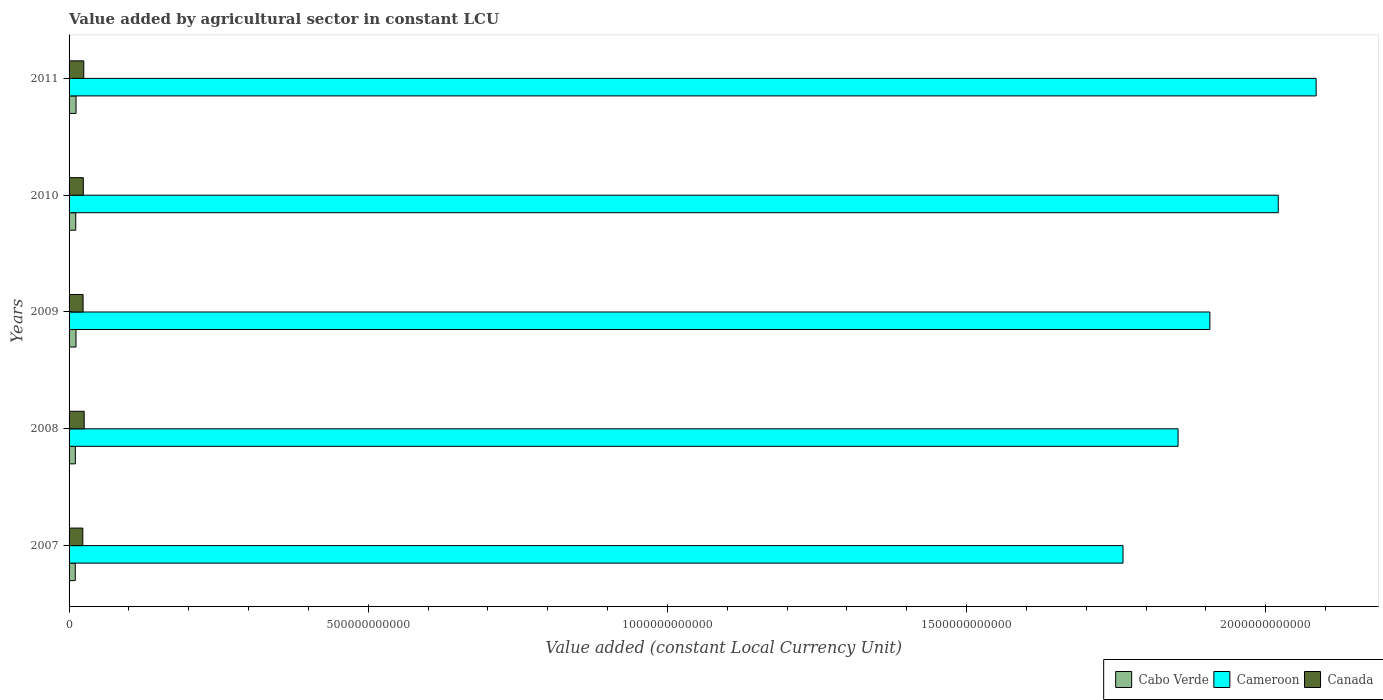How many different coloured bars are there?
Ensure brevity in your answer.  3. How many groups of bars are there?
Ensure brevity in your answer.  5. Are the number of bars on each tick of the Y-axis equal?
Your answer should be very brief. Yes. How many bars are there on the 4th tick from the top?
Give a very brief answer. 3. How many bars are there on the 3rd tick from the bottom?
Keep it short and to the point. 3. What is the value added by agricultural sector in Canada in 2007?
Provide a short and direct response. 2.29e+1. Across all years, what is the maximum value added by agricultural sector in Canada?
Your response must be concise. 2.52e+1. Across all years, what is the minimum value added by agricultural sector in Canada?
Offer a terse response. 2.29e+1. In which year was the value added by agricultural sector in Cabo Verde minimum?
Offer a terse response. 2007. What is the total value added by agricultural sector in Cabo Verde in the graph?
Your answer should be very brief. 5.53e+1. What is the difference between the value added by agricultural sector in Canada in 2007 and that in 2009?
Your response must be concise. -4.77e+08. What is the difference between the value added by agricultural sector in Cabo Verde in 2009 and the value added by agricultural sector in Cameroon in 2007?
Make the answer very short. -1.75e+12. What is the average value added by agricultural sector in Cameroon per year?
Offer a terse response. 1.93e+12. In the year 2008, what is the difference between the value added by agricultural sector in Cabo Verde and value added by agricultural sector in Canada?
Offer a very short reply. -1.47e+1. In how many years, is the value added by agricultural sector in Canada greater than 1800000000000 LCU?
Give a very brief answer. 0. What is the ratio of the value added by agricultural sector in Canada in 2008 to that in 2009?
Keep it short and to the point. 1.08. Is the value added by agricultural sector in Cameroon in 2009 less than that in 2010?
Ensure brevity in your answer.  Yes. What is the difference between the highest and the second highest value added by agricultural sector in Cabo Verde?
Provide a short and direct response. 6.91e+07. What is the difference between the highest and the lowest value added by agricultural sector in Cabo Verde?
Keep it short and to the point. 1.27e+09. In how many years, is the value added by agricultural sector in Cameroon greater than the average value added by agricultural sector in Cameroon taken over all years?
Provide a succinct answer. 2. What does the 3rd bar from the top in 2011 represents?
Provide a short and direct response. Cabo Verde. What does the 2nd bar from the bottom in 2011 represents?
Provide a succinct answer. Cameroon. How many bars are there?
Ensure brevity in your answer.  15. How many years are there in the graph?
Your answer should be compact. 5. What is the difference between two consecutive major ticks on the X-axis?
Your answer should be very brief. 5.00e+11. Are the values on the major ticks of X-axis written in scientific E-notation?
Keep it short and to the point. No. Where does the legend appear in the graph?
Offer a very short reply. Bottom right. What is the title of the graph?
Keep it short and to the point. Value added by agricultural sector in constant LCU. Does "Azerbaijan" appear as one of the legend labels in the graph?
Make the answer very short. No. What is the label or title of the X-axis?
Keep it short and to the point. Value added (constant Local Currency Unit). What is the label or title of the Y-axis?
Offer a very short reply. Years. What is the Value added (constant Local Currency Unit) of Cabo Verde in 2007?
Provide a short and direct response. 1.04e+1. What is the Value added (constant Local Currency Unit) in Cameroon in 2007?
Provide a short and direct response. 1.76e+12. What is the Value added (constant Local Currency Unit) in Canada in 2007?
Give a very brief answer. 2.29e+1. What is the Value added (constant Local Currency Unit) of Cabo Verde in 2008?
Offer a terse response. 1.05e+1. What is the Value added (constant Local Currency Unit) in Cameroon in 2008?
Provide a succinct answer. 1.85e+12. What is the Value added (constant Local Currency Unit) in Canada in 2008?
Your answer should be very brief. 2.52e+1. What is the Value added (constant Local Currency Unit) of Cabo Verde in 2009?
Your response must be concise. 1.16e+1. What is the Value added (constant Local Currency Unit) in Cameroon in 2009?
Offer a very short reply. 1.91e+12. What is the Value added (constant Local Currency Unit) in Canada in 2009?
Offer a very short reply. 2.34e+1. What is the Value added (constant Local Currency Unit) in Cabo Verde in 2010?
Provide a succinct answer. 1.12e+1. What is the Value added (constant Local Currency Unit) in Cameroon in 2010?
Offer a very short reply. 2.02e+12. What is the Value added (constant Local Currency Unit) in Canada in 2010?
Provide a short and direct response. 2.38e+1. What is the Value added (constant Local Currency Unit) of Cabo Verde in 2011?
Your answer should be compact. 1.17e+1. What is the Value added (constant Local Currency Unit) of Cameroon in 2011?
Your answer should be very brief. 2.08e+12. What is the Value added (constant Local Currency Unit) of Canada in 2011?
Ensure brevity in your answer.  2.46e+1. Across all years, what is the maximum Value added (constant Local Currency Unit) in Cabo Verde?
Provide a short and direct response. 1.17e+1. Across all years, what is the maximum Value added (constant Local Currency Unit) in Cameroon?
Give a very brief answer. 2.08e+12. Across all years, what is the maximum Value added (constant Local Currency Unit) of Canada?
Your response must be concise. 2.52e+1. Across all years, what is the minimum Value added (constant Local Currency Unit) of Cabo Verde?
Ensure brevity in your answer.  1.04e+1. Across all years, what is the minimum Value added (constant Local Currency Unit) of Cameroon?
Ensure brevity in your answer.  1.76e+12. Across all years, what is the minimum Value added (constant Local Currency Unit) of Canada?
Provide a succinct answer. 2.29e+1. What is the total Value added (constant Local Currency Unit) in Cabo Verde in the graph?
Your response must be concise. 5.53e+1. What is the total Value added (constant Local Currency Unit) of Cameroon in the graph?
Ensure brevity in your answer.  9.63e+12. What is the total Value added (constant Local Currency Unit) in Canada in the graph?
Keep it short and to the point. 1.20e+11. What is the difference between the Value added (constant Local Currency Unit) of Cabo Verde in 2007 and that in 2008?
Offer a terse response. -9.91e+07. What is the difference between the Value added (constant Local Currency Unit) of Cameroon in 2007 and that in 2008?
Keep it short and to the point. -9.20e+1. What is the difference between the Value added (constant Local Currency Unit) of Canada in 2007 and that in 2008?
Your answer should be very brief. -2.30e+09. What is the difference between the Value added (constant Local Currency Unit) of Cabo Verde in 2007 and that in 2009?
Offer a terse response. -1.20e+09. What is the difference between the Value added (constant Local Currency Unit) of Cameroon in 2007 and that in 2009?
Your answer should be compact. -1.45e+11. What is the difference between the Value added (constant Local Currency Unit) of Canada in 2007 and that in 2009?
Make the answer very short. -4.77e+08. What is the difference between the Value added (constant Local Currency Unit) in Cabo Verde in 2007 and that in 2010?
Provide a succinct answer. -7.83e+08. What is the difference between the Value added (constant Local Currency Unit) of Cameroon in 2007 and that in 2010?
Provide a succinct answer. -2.59e+11. What is the difference between the Value added (constant Local Currency Unit) in Canada in 2007 and that in 2010?
Your answer should be compact. -8.49e+08. What is the difference between the Value added (constant Local Currency Unit) in Cabo Verde in 2007 and that in 2011?
Your answer should be compact. -1.27e+09. What is the difference between the Value added (constant Local Currency Unit) of Cameroon in 2007 and that in 2011?
Provide a short and direct response. -3.23e+11. What is the difference between the Value added (constant Local Currency Unit) of Canada in 2007 and that in 2011?
Keep it short and to the point. -1.64e+09. What is the difference between the Value added (constant Local Currency Unit) in Cabo Verde in 2008 and that in 2009?
Provide a short and direct response. -1.10e+09. What is the difference between the Value added (constant Local Currency Unit) of Cameroon in 2008 and that in 2009?
Your answer should be very brief. -5.31e+1. What is the difference between the Value added (constant Local Currency Unit) of Canada in 2008 and that in 2009?
Make the answer very short. 1.82e+09. What is the difference between the Value added (constant Local Currency Unit) in Cabo Verde in 2008 and that in 2010?
Your answer should be very brief. -6.84e+08. What is the difference between the Value added (constant Local Currency Unit) in Cameroon in 2008 and that in 2010?
Provide a succinct answer. -1.67e+11. What is the difference between the Value added (constant Local Currency Unit) in Canada in 2008 and that in 2010?
Offer a very short reply. 1.45e+09. What is the difference between the Value added (constant Local Currency Unit) of Cabo Verde in 2008 and that in 2011?
Give a very brief answer. -1.17e+09. What is the difference between the Value added (constant Local Currency Unit) of Cameroon in 2008 and that in 2011?
Provide a short and direct response. -2.31e+11. What is the difference between the Value added (constant Local Currency Unit) of Canada in 2008 and that in 2011?
Offer a very short reply. 6.58e+08. What is the difference between the Value added (constant Local Currency Unit) in Cabo Verde in 2009 and that in 2010?
Your response must be concise. 4.20e+08. What is the difference between the Value added (constant Local Currency Unit) in Cameroon in 2009 and that in 2010?
Your answer should be compact. -1.14e+11. What is the difference between the Value added (constant Local Currency Unit) of Canada in 2009 and that in 2010?
Provide a succinct answer. -3.73e+08. What is the difference between the Value added (constant Local Currency Unit) in Cabo Verde in 2009 and that in 2011?
Provide a succinct answer. -6.91e+07. What is the difference between the Value added (constant Local Currency Unit) of Cameroon in 2009 and that in 2011?
Provide a succinct answer. -1.78e+11. What is the difference between the Value added (constant Local Currency Unit) of Canada in 2009 and that in 2011?
Give a very brief answer. -1.16e+09. What is the difference between the Value added (constant Local Currency Unit) in Cabo Verde in 2010 and that in 2011?
Keep it short and to the point. -4.90e+08. What is the difference between the Value added (constant Local Currency Unit) of Cameroon in 2010 and that in 2011?
Your response must be concise. -6.33e+1. What is the difference between the Value added (constant Local Currency Unit) of Canada in 2010 and that in 2011?
Offer a terse response. -7.89e+08. What is the difference between the Value added (constant Local Currency Unit) of Cabo Verde in 2007 and the Value added (constant Local Currency Unit) of Cameroon in 2008?
Your response must be concise. -1.84e+12. What is the difference between the Value added (constant Local Currency Unit) of Cabo Verde in 2007 and the Value added (constant Local Currency Unit) of Canada in 2008?
Your answer should be compact. -1.48e+1. What is the difference between the Value added (constant Local Currency Unit) of Cameroon in 2007 and the Value added (constant Local Currency Unit) of Canada in 2008?
Provide a succinct answer. 1.74e+12. What is the difference between the Value added (constant Local Currency Unit) in Cabo Verde in 2007 and the Value added (constant Local Currency Unit) in Cameroon in 2009?
Make the answer very short. -1.90e+12. What is the difference between the Value added (constant Local Currency Unit) in Cabo Verde in 2007 and the Value added (constant Local Currency Unit) in Canada in 2009?
Provide a succinct answer. -1.30e+1. What is the difference between the Value added (constant Local Currency Unit) of Cameroon in 2007 and the Value added (constant Local Currency Unit) of Canada in 2009?
Your response must be concise. 1.74e+12. What is the difference between the Value added (constant Local Currency Unit) in Cabo Verde in 2007 and the Value added (constant Local Currency Unit) in Cameroon in 2010?
Your response must be concise. -2.01e+12. What is the difference between the Value added (constant Local Currency Unit) in Cabo Verde in 2007 and the Value added (constant Local Currency Unit) in Canada in 2010?
Your answer should be compact. -1.34e+1. What is the difference between the Value added (constant Local Currency Unit) of Cameroon in 2007 and the Value added (constant Local Currency Unit) of Canada in 2010?
Keep it short and to the point. 1.74e+12. What is the difference between the Value added (constant Local Currency Unit) of Cabo Verde in 2007 and the Value added (constant Local Currency Unit) of Cameroon in 2011?
Your answer should be very brief. -2.07e+12. What is the difference between the Value added (constant Local Currency Unit) in Cabo Verde in 2007 and the Value added (constant Local Currency Unit) in Canada in 2011?
Make the answer very short. -1.42e+1. What is the difference between the Value added (constant Local Currency Unit) in Cameroon in 2007 and the Value added (constant Local Currency Unit) in Canada in 2011?
Your response must be concise. 1.74e+12. What is the difference between the Value added (constant Local Currency Unit) of Cabo Verde in 2008 and the Value added (constant Local Currency Unit) of Cameroon in 2009?
Give a very brief answer. -1.90e+12. What is the difference between the Value added (constant Local Currency Unit) of Cabo Verde in 2008 and the Value added (constant Local Currency Unit) of Canada in 2009?
Provide a succinct answer. -1.29e+1. What is the difference between the Value added (constant Local Currency Unit) in Cameroon in 2008 and the Value added (constant Local Currency Unit) in Canada in 2009?
Your answer should be very brief. 1.83e+12. What is the difference between the Value added (constant Local Currency Unit) of Cabo Verde in 2008 and the Value added (constant Local Currency Unit) of Cameroon in 2010?
Your answer should be compact. -2.01e+12. What is the difference between the Value added (constant Local Currency Unit) in Cabo Verde in 2008 and the Value added (constant Local Currency Unit) in Canada in 2010?
Provide a succinct answer. -1.33e+1. What is the difference between the Value added (constant Local Currency Unit) in Cameroon in 2008 and the Value added (constant Local Currency Unit) in Canada in 2010?
Give a very brief answer. 1.83e+12. What is the difference between the Value added (constant Local Currency Unit) of Cabo Verde in 2008 and the Value added (constant Local Currency Unit) of Cameroon in 2011?
Your answer should be compact. -2.07e+12. What is the difference between the Value added (constant Local Currency Unit) of Cabo Verde in 2008 and the Value added (constant Local Currency Unit) of Canada in 2011?
Make the answer very short. -1.41e+1. What is the difference between the Value added (constant Local Currency Unit) of Cameroon in 2008 and the Value added (constant Local Currency Unit) of Canada in 2011?
Keep it short and to the point. 1.83e+12. What is the difference between the Value added (constant Local Currency Unit) of Cabo Verde in 2009 and the Value added (constant Local Currency Unit) of Cameroon in 2010?
Your answer should be very brief. -2.01e+12. What is the difference between the Value added (constant Local Currency Unit) in Cabo Verde in 2009 and the Value added (constant Local Currency Unit) in Canada in 2010?
Your response must be concise. -1.22e+1. What is the difference between the Value added (constant Local Currency Unit) of Cameroon in 2009 and the Value added (constant Local Currency Unit) of Canada in 2010?
Make the answer very short. 1.88e+12. What is the difference between the Value added (constant Local Currency Unit) in Cabo Verde in 2009 and the Value added (constant Local Currency Unit) in Cameroon in 2011?
Give a very brief answer. -2.07e+12. What is the difference between the Value added (constant Local Currency Unit) of Cabo Verde in 2009 and the Value added (constant Local Currency Unit) of Canada in 2011?
Your response must be concise. -1.30e+1. What is the difference between the Value added (constant Local Currency Unit) of Cameroon in 2009 and the Value added (constant Local Currency Unit) of Canada in 2011?
Offer a very short reply. 1.88e+12. What is the difference between the Value added (constant Local Currency Unit) of Cabo Verde in 2010 and the Value added (constant Local Currency Unit) of Cameroon in 2011?
Offer a terse response. -2.07e+12. What is the difference between the Value added (constant Local Currency Unit) in Cabo Verde in 2010 and the Value added (constant Local Currency Unit) in Canada in 2011?
Keep it short and to the point. -1.34e+1. What is the difference between the Value added (constant Local Currency Unit) in Cameroon in 2010 and the Value added (constant Local Currency Unit) in Canada in 2011?
Keep it short and to the point. 2.00e+12. What is the average Value added (constant Local Currency Unit) in Cabo Verde per year?
Provide a succinct answer. 1.11e+1. What is the average Value added (constant Local Currency Unit) in Cameroon per year?
Your answer should be compact. 1.93e+12. What is the average Value added (constant Local Currency Unit) of Canada per year?
Your response must be concise. 2.40e+1. In the year 2007, what is the difference between the Value added (constant Local Currency Unit) of Cabo Verde and Value added (constant Local Currency Unit) of Cameroon?
Your answer should be very brief. -1.75e+12. In the year 2007, what is the difference between the Value added (constant Local Currency Unit) in Cabo Verde and Value added (constant Local Currency Unit) in Canada?
Provide a succinct answer. -1.25e+1. In the year 2007, what is the difference between the Value added (constant Local Currency Unit) of Cameroon and Value added (constant Local Currency Unit) of Canada?
Your answer should be compact. 1.74e+12. In the year 2008, what is the difference between the Value added (constant Local Currency Unit) in Cabo Verde and Value added (constant Local Currency Unit) in Cameroon?
Provide a short and direct response. -1.84e+12. In the year 2008, what is the difference between the Value added (constant Local Currency Unit) of Cabo Verde and Value added (constant Local Currency Unit) of Canada?
Your answer should be very brief. -1.47e+1. In the year 2008, what is the difference between the Value added (constant Local Currency Unit) of Cameroon and Value added (constant Local Currency Unit) of Canada?
Offer a terse response. 1.83e+12. In the year 2009, what is the difference between the Value added (constant Local Currency Unit) of Cabo Verde and Value added (constant Local Currency Unit) of Cameroon?
Ensure brevity in your answer.  -1.90e+12. In the year 2009, what is the difference between the Value added (constant Local Currency Unit) of Cabo Verde and Value added (constant Local Currency Unit) of Canada?
Offer a very short reply. -1.18e+1. In the year 2009, what is the difference between the Value added (constant Local Currency Unit) in Cameroon and Value added (constant Local Currency Unit) in Canada?
Make the answer very short. 1.88e+12. In the year 2010, what is the difference between the Value added (constant Local Currency Unit) of Cabo Verde and Value added (constant Local Currency Unit) of Cameroon?
Keep it short and to the point. -2.01e+12. In the year 2010, what is the difference between the Value added (constant Local Currency Unit) of Cabo Verde and Value added (constant Local Currency Unit) of Canada?
Offer a very short reply. -1.26e+1. In the year 2010, what is the difference between the Value added (constant Local Currency Unit) of Cameroon and Value added (constant Local Currency Unit) of Canada?
Your answer should be compact. 2.00e+12. In the year 2011, what is the difference between the Value added (constant Local Currency Unit) of Cabo Verde and Value added (constant Local Currency Unit) of Cameroon?
Provide a short and direct response. -2.07e+12. In the year 2011, what is the difference between the Value added (constant Local Currency Unit) in Cabo Verde and Value added (constant Local Currency Unit) in Canada?
Provide a succinct answer. -1.29e+1. In the year 2011, what is the difference between the Value added (constant Local Currency Unit) of Cameroon and Value added (constant Local Currency Unit) of Canada?
Provide a short and direct response. 2.06e+12. What is the ratio of the Value added (constant Local Currency Unit) in Cabo Verde in 2007 to that in 2008?
Give a very brief answer. 0.99. What is the ratio of the Value added (constant Local Currency Unit) of Cameroon in 2007 to that in 2008?
Your answer should be compact. 0.95. What is the ratio of the Value added (constant Local Currency Unit) in Canada in 2007 to that in 2008?
Ensure brevity in your answer.  0.91. What is the ratio of the Value added (constant Local Currency Unit) in Cabo Verde in 2007 to that in 2009?
Keep it short and to the point. 0.9. What is the ratio of the Value added (constant Local Currency Unit) in Cameroon in 2007 to that in 2009?
Give a very brief answer. 0.92. What is the ratio of the Value added (constant Local Currency Unit) in Canada in 2007 to that in 2009?
Keep it short and to the point. 0.98. What is the ratio of the Value added (constant Local Currency Unit) in Cabo Verde in 2007 to that in 2010?
Your response must be concise. 0.93. What is the ratio of the Value added (constant Local Currency Unit) in Cameroon in 2007 to that in 2010?
Offer a terse response. 0.87. What is the ratio of the Value added (constant Local Currency Unit) of Cabo Verde in 2007 to that in 2011?
Ensure brevity in your answer.  0.89. What is the ratio of the Value added (constant Local Currency Unit) of Cameroon in 2007 to that in 2011?
Ensure brevity in your answer.  0.85. What is the ratio of the Value added (constant Local Currency Unit) in Canada in 2007 to that in 2011?
Your answer should be compact. 0.93. What is the ratio of the Value added (constant Local Currency Unit) in Cabo Verde in 2008 to that in 2009?
Your answer should be very brief. 0.9. What is the ratio of the Value added (constant Local Currency Unit) in Cameroon in 2008 to that in 2009?
Ensure brevity in your answer.  0.97. What is the ratio of the Value added (constant Local Currency Unit) of Canada in 2008 to that in 2009?
Your answer should be compact. 1.08. What is the ratio of the Value added (constant Local Currency Unit) in Cabo Verde in 2008 to that in 2010?
Offer a terse response. 0.94. What is the ratio of the Value added (constant Local Currency Unit) in Cameroon in 2008 to that in 2010?
Provide a succinct answer. 0.92. What is the ratio of the Value added (constant Local Currency Unit) in Canada in 2008 to that in 2010?
Your answer should be compact. 1.06. What is the ratio of the Value added (constant Local Currency Unit) of Cabo Verde in 2008 to that in 2011?
Provide a short and direct response. 0.9. What is the ratio of the Value added (constant Local Currency Unit) in Cameroon in 2008 to that in 2011?
Your answer should be very brief. 0.89. What is the ratio of the Value added (constant Local Currency Unit) in Canada in 2008 to that in 2011?
Provide a short and direct response. 1.03. What is the ratio of the Value added (constant Local Currency Unit) of Cabo Verde in 2009 to that in 2010?
Make the answer very short. 1.04. What is the ratio of the Value added (constant Local Currency Unit) in Cameroon in 2009 to that in 2010?
Provide a short and direct response. 0.94. What is the ratio of the Value added (constant Local Currency Unit) in Canada in 2009 to that in 2010?
Provide a succinct answer. 0.98. What is the ratio of the Value added (constant Local Currency Unit) of Cameroon in 2009 to that in 2011?
Your response must be concise. 0.91. What is the ratio of the Value added (constant Local Currency Unit) in Canada in 2009 to that in 2011?
Offer a very short reply. 0.95. What is the ratio of the Value added (constant Local Currency Unit) of Cabo Verde in 2010 to that in 2011?
Your answer should be compact. 0.96. What is the ratio of the Value added (constant Local Currency Unit) of Cameroon in 2010 to that in 2011?
Your response must be concise. 0.97. What is the ratio of the Value added (constant Local Currency Unit) of Canada in 2010 to that in 2011?
Provide a short and direct response. 0.97. What is the difference between the highest and the second highest Value added (constant Local Currency Unit) of Cabo Verde?
Offer a very short reply. 6.91e+07. What is the difference between the highest and the second highest Value added (constant Local Currency Unit) in Cameroon?
Your answer should be compact. 6.33e+1. What is the difference between the highest and the second highest Value added (constant Local Currency Unit) of Canada?
Provide a short and direct response. 6.58e+08. What is the difference between the highest and the lowest Value added (constant Local Currency Unit) of Cabo Verde?
Provide a succinct answer. 1.27e+09. What is the difference between the highest and the lowest Value added (constant Local Currency Unit) of Cameroon?
Provide a short and direct response. 3.23e+11. What is the difference between the highest and the lowest Value added (constant Local Currency Unit) of Canada?
Your response must be concise. 2.30e+09. 